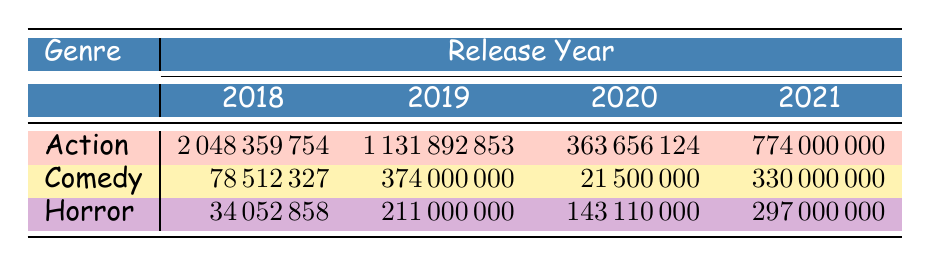What is the box office revenue for the highest-grossing Action film in 2018? The highest-grossing Action film in 2018 listed in the table is "Avengers: Infinity War," which earned a box office revenue of 2048359754.
Answer: 2048359754 Which genre had the lowest box office revenue in 2020? In 2020, the box office revenues for each genre are as follows: Action (363656124), Comedy (21500000), and Horror (143110000). The lowest value among these is for Comedy, with 21500000.
Answer: Comedy True or False: The box office revenue for Horror movies increased every year from 2018 to 2021. Looking at the box office revenues for Horror films: 2018: 34052858, 2019: 211000000, 2020: 143110000, and 2021: 297000000. The revenue decreased from 2018 to 2019, then decreased again from 2019 to 2020, before increasing in 2021. Therefore, the statement is False.
Answer: False What is the total box office revenue for Comedy films across all four years? The box office revenues for Comedy films are: 2018: 78512327, 2019: 374000000, 2020: 21500000, and 2021: 330000000. We sum these values: 78512327 + 374000000 + 21500000 + 330000000 = 888511327.
Answer: 888511327 Which genre had the highest box office revenue on average from 2018 to 2021? The box office revenues for each genre are as follows: Action - (2048359754 + 1131892853 + 363656124 + 774000000) / 4; Comedy - (78512327 + 374000000 + 21500000 + 330000000) / 4; Horror - (34052858 + 211000000 + 143110000 + 297000000) / 4. Calculating these gives us average revenues: Action: 740532557.25, Comedy: 222127577.5, Horror: 185775714.5. The highest average is for Action at 740532557.25.
Answer: Action 